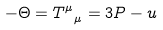Convert formula to latex. <formula><loc_0><loc_0><loc_500><loc_500>- \Theta = T ^ { \mu } _ { \ \mu } = 3 P - u</formula> 